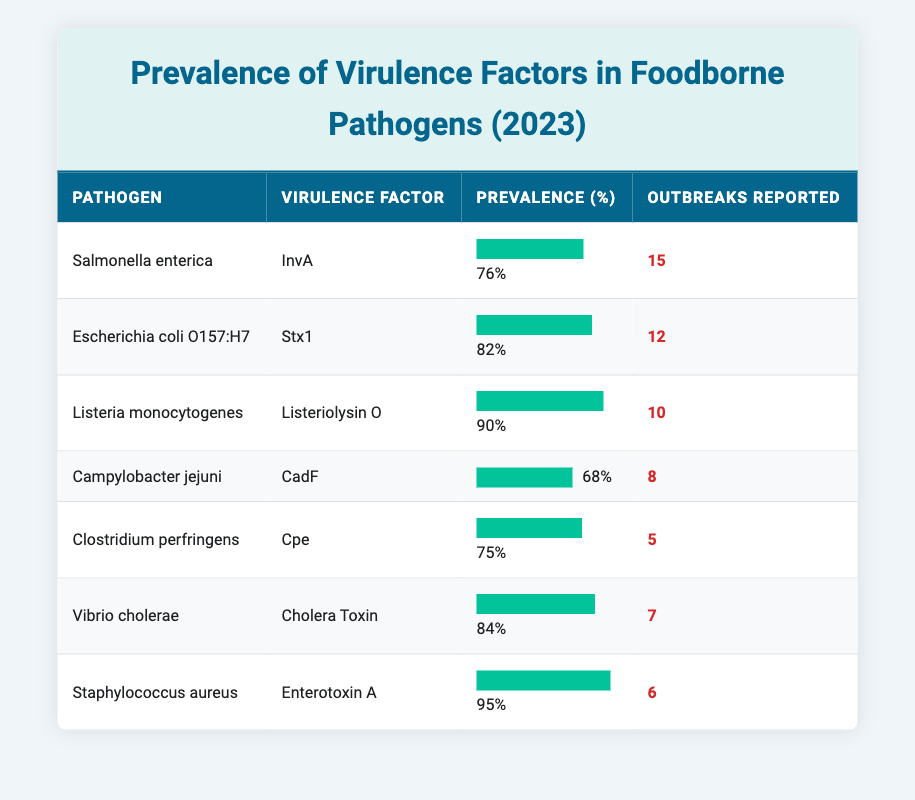What is the prevalence percentage of Listeriolysin O in Listeria monocytogenes? The table directly lists the prevalence percentage for each pathogen and associated virulence factor. For Listeria monocytogenes, the virulence factor Listeriolysin O has a prevalence percentage of 90%.
Answer: 90% Which pathogen has the highest prevalence of its virulence factor? By scanning through the prevalence percentages in the table, we find that Staphylococcus aureus with Enterotoxin A has the highest prevalence at 95%.
Answer: Staphylococcus aureus What is the average prevalence percentage of all listed virulence factors? To determine the average, we sum the prevalence percentages: 76 + 82 + 90 + 68 + 75 + 84 + 95 = 570. Then, divide by the number of pathogens, which is 7. Thus, 570 / 7 = 81.43.
Answer: 81.43 Did more than 10 outbreaks get reported for Salmonella enterica? The table indicates that Salmonella enterica had 15 outbreaks reported. Since 15 is greater than 10, the answer to this question is yes.
Answer: Yes Which virulence factor has the lowest prevalence and what percentage is it? Looking through the prevalence percentages, Campylobacter jejuni with the virulence factor CadF has the lowest percentage at 68%. Therefore, the answer combines both the identification of the lowest value and the associated percentage.
Answer: CadF, 68% Calculate the difference in outbreaks reported between Staphylococcus aureus and Clostridium perfringens. Staphylococcus aureus has 6 outbreaks reported and Clostridium perfringens has 5. The difference is calculated as 6 - 5 = 1.
Answer: 1 Is Vibrio cholerae's virulence factor prevalence less than 80%? The prevalence for Vibrio cholerae with Cholera Toxin is reported at 84%, which is not less than 80%. Therefore, the answer is no.
Answer: No What is the total number of outbreaks reported for all pathogens combined? To find the total, we sum the outbreaks reported: 15 + 12 + 10 + 8 + 5 + 7 + 6 = 63. Thus, the total number of outbreaks reported across all pathogens is 63.
Answer: 63 